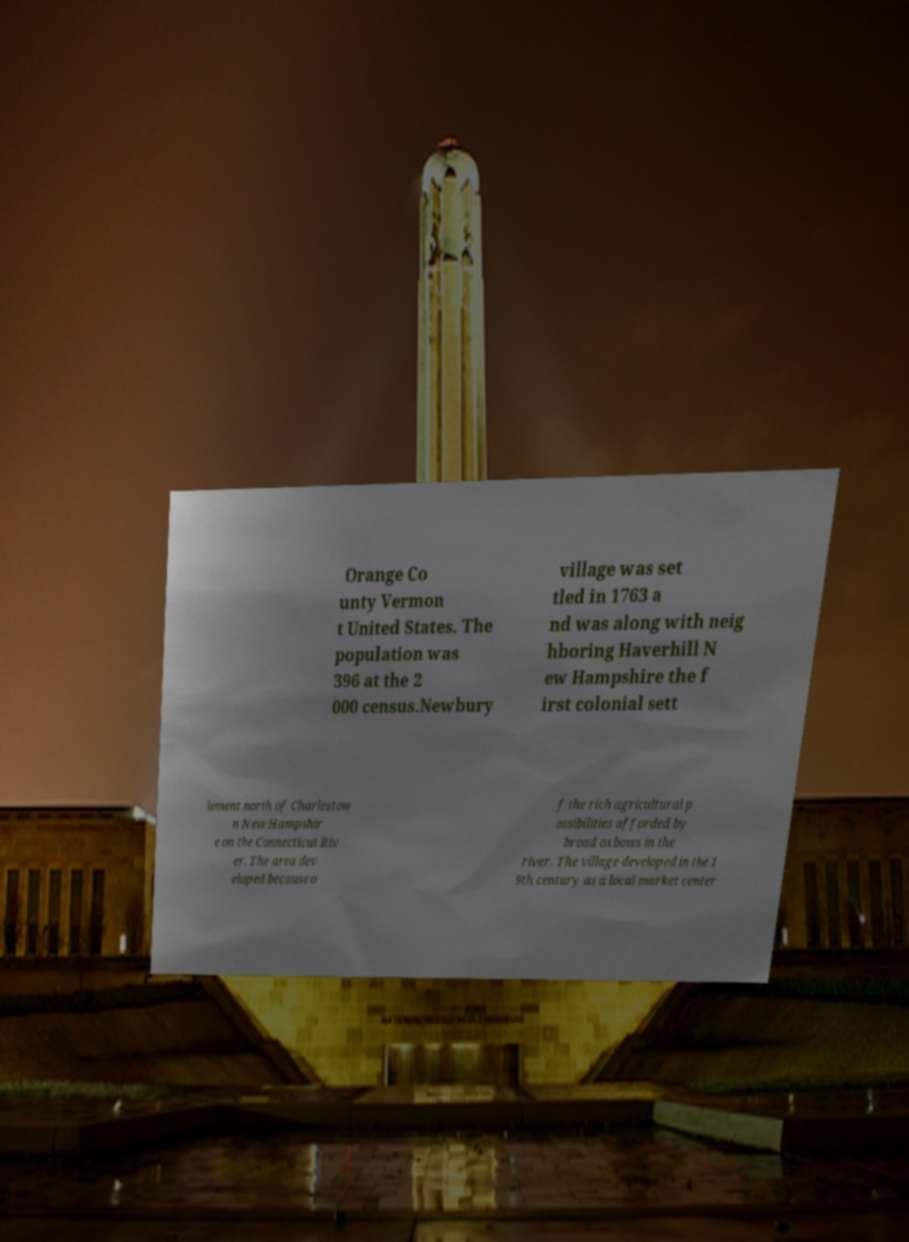Could you extract and type out the text from this image? Orange Co unty Vermon t United States. The population was 396 at the 2 000 census.Newbury village was set tled in 1763 a nd was along with neig hboring Haverhill N ew Hampshire the f irst colonial sett lement north of Charlestow n New Hampshir e on the Connecticut Riv er. The area dev eloped because o f the rich agricultural p ossibilities afforded by broad oxbows in the river. The village developed in the 1 9th century as a local market center 